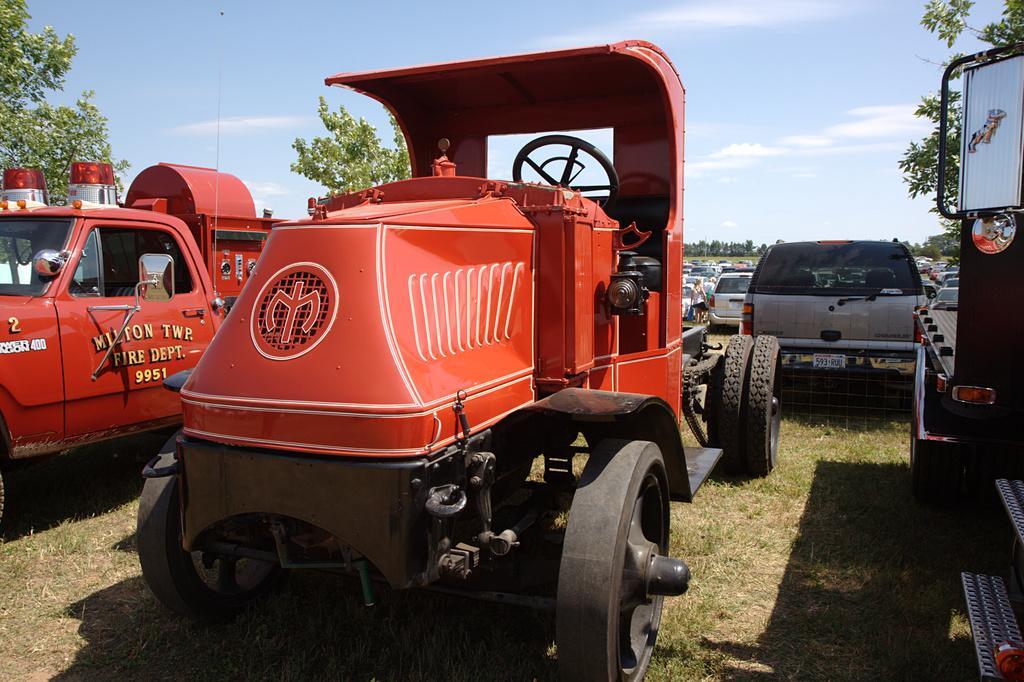Please provide a concise description of this image. In the image there are different types of vehicles parked on the land that is covered with grass and around the vehicles there are trees. 